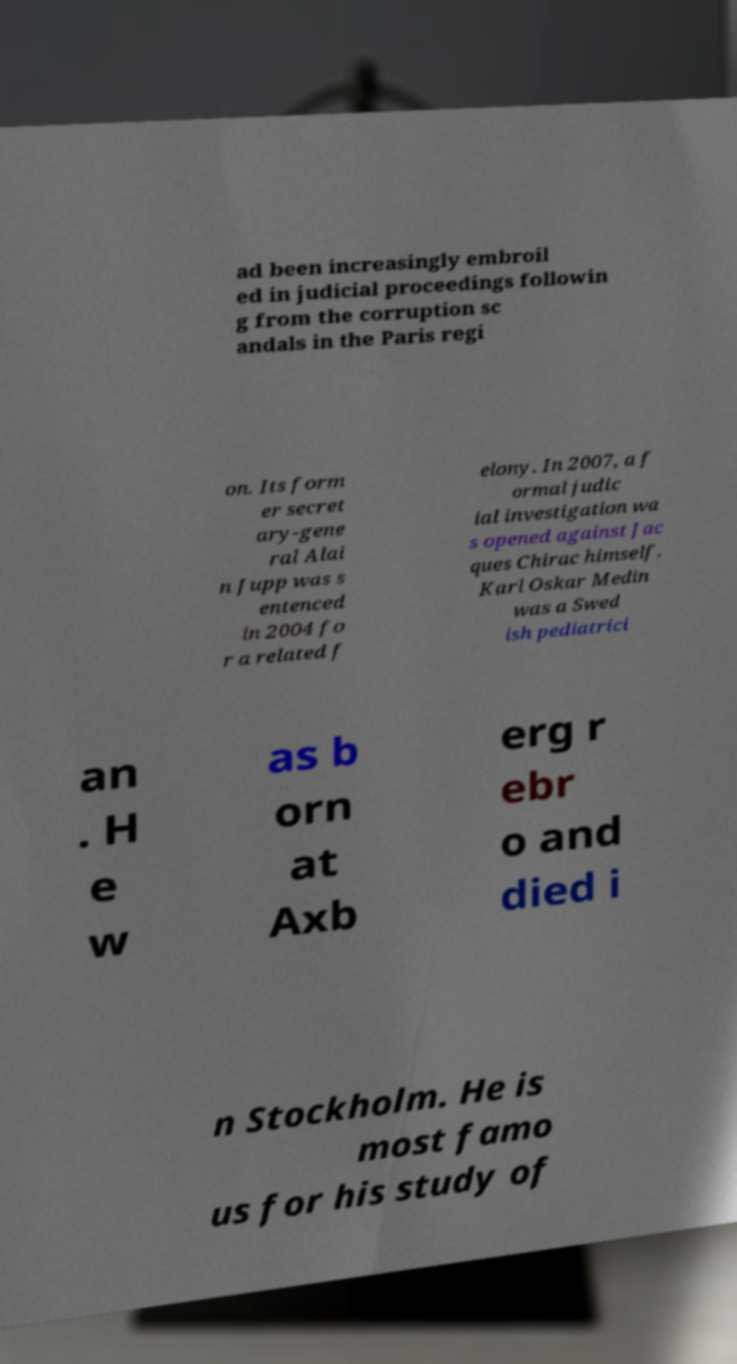For documentation purposes, I need the text within this image transcribed. Could you provide that? ad been increasingly embroil ed in judicial proceedings followin g from the corruption sc andals in the Paris regi on. Its form er secret ary-gene ral Alai n Jupp was s entenced in 2004 fo r a related f elony. In 2007, a f ormal judic ial investigation wa s opened against Jac ques Chirac himself. Karl Oskar Medin was a Swed ish pediatrici an . H e w as b orn at Axb erg r ebr o and died i n Stockholm. He is most famo us for his study of 